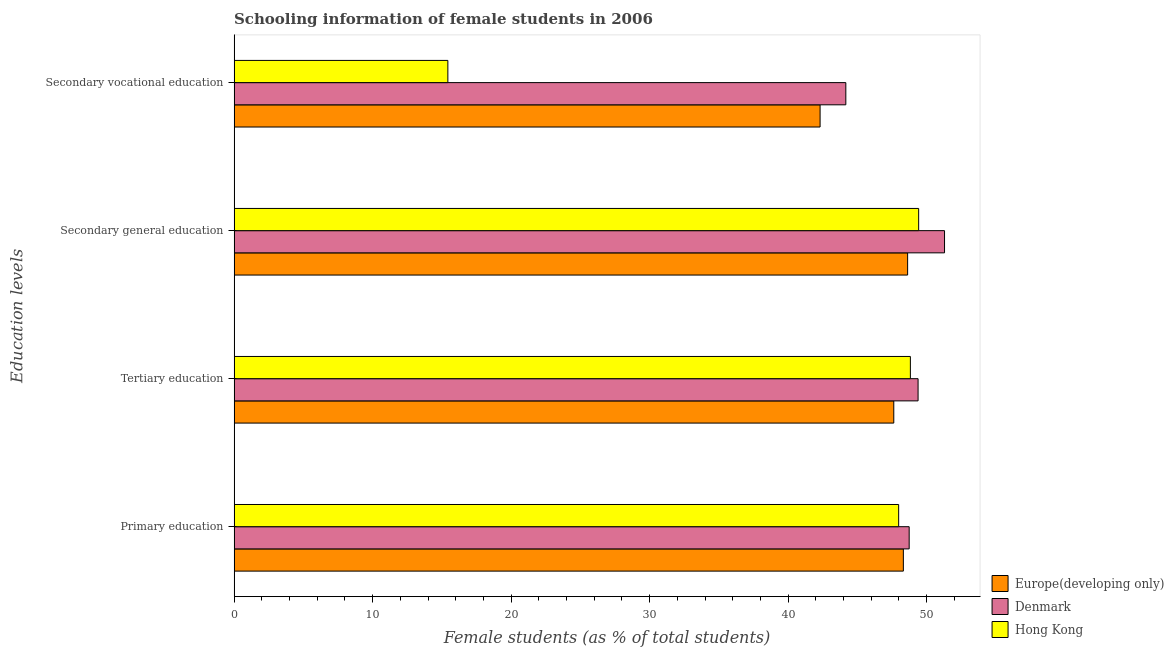How many groups of bars are there?
Give a very brief answer. 4. How many bars are there on the 1st tick from the bottom?
Provide a short and direct response. 3. What is the label of the 2nd group of bars from the top?
Your response must be concise. Secondary general education. What is the percentage of female students in secondary education in Hong Kong?
Keep it short and to the point. 49.42. Across all countries, what is the maximum percentage of female students in secondary vocational education?
Give a very brief answer. 44.16. Across all countries, what is the minimum percentage of female students in secondary vocational education?
Make the answer very short. 15.43. In which country was the percentage of female students in secondary vocational education minimum?
Give a very brief answer. Hong Kong. What is the total percentage of female students in primary education in the graph?
Your response must be concise. 145.03. What is the difference between the percentage of female students in secondary vocational education in Europe(developing only) and that in Hong Kong?
Ensure brevity in your answer.  26.88. What is the difference between the percentage of female students in primary education in Europe(developing only) and the percentage of female students in tertiary education in Hong Kong?
Ensure brevity in your answer.  -0.51. What is the average percentage of female students in secondary education per country?
Offer a very short reply. 49.78. What is the difference between the percentage of female students in secondary education and percentage of female students in tertiary education in Hong Kong?
Your response must be concise. 0.6. In how many countries, is the percentage of female students in tertiary education greater than 10 %?
Offer a terse response. 3. What is the ratio of the percentage of female students in tertiary education in Hong Kong to that in Denmark?
Your response must be concise. 0.99. Is the difference between the percentage of female students in primary education in Denmark and Hong Kong greater than the difference between the percentage of female students in secondary education in Denmark and Hong Kong?
Your answer should be very brief. No. What is the difference between the highest and the second highest percentage of female students in primary education?
Provide a short and direct response. 0.42. What is the difference between the highest and the lowest percentage of female students in tertiary education?
Your answer should be very brief. 1.75. What does the 3rd bar from the top in Secondary vocational education represents?
Provide a succinct answer. Europe(developing only). What does the 2nd bar from the bottom in Tertiary education represents?
Provide a short and direct response. Denmark. How many bars are there?
Offer a very short reply. 12. What is the difference between two consecutive major ticks on the X-axis?
Offer a very short reply. 10. Does the graph contain grids?
Ensure brevity in your answer.  No. Where does the legend appear in the graph?
Give a very brief answer. Bottom right. What is the title of the graph?
Provide a short and direct response. Schooling information of female students in 2006. What is the label or title of the X-axis?
Offer a very short reply. Female students (as % of total students). What is the label or title of the Y-axis?
Your response must be concise. Education levels. What is the Female students (as % of total students) of Europe(developing only) in Primary education?
Give a very brief answer. 48.32. What is the Female students (as % of total students) in Denmark in Primary education?
Provide a short and direct response. 48.74. What is the Female students (as % of total students) in Hong Kong in Primary education?
Give a very brief answer. 47.98. What is the Female students (as % of total students) in Europe(developing only) in Tertiary education?
Give a very brief answer. 47.63. What is the Female students (as % of total students) of Denmark in Tertiary education?
Provide a succinct answer. 49.38. What is the Female students (as % of total students) of Hong Kong in Tertiary education?
Make the answer very short. 48.82. What is the Female students (as % of total students) of Europe(developing only) in Secondary general education?
Ensure brevity in your answer.  48.63. What is the Female students (as % of total students) in Denmark in Secondary general education?
Offer a terse response. 51.29. What is the Female students (as % of total students) in Hong Kong in Secondary general education?
Your answer should be compact. 49.42. What is the Female students (as % of total students) of Europe(developing only) in Secondary vocational education?
Your answer should be compact. 42.31. What is the Female students (as % of total students) in Denmark in Secondary vocational education?
Provide a short and direct response. 44.16. What is the Female students (as % of total students) of Hong Kong in Secondary vocational education?
Give a very brief answer. 15.43. Across all Education levels, what is the maximum Female students (as % of total students) of Europe(developing only)?
Give a very brief answer. 48.63. Across all Education levels, what is the maximum Female students (as % of total students) of Denmark?
Make the answer very short. 51.29. Across all Education levels, what is the maximum Female students (as % of total students) of Hong Kong?
Offer a terse response. 49.42. Across all Education levels, what is the minimum Female students (as % of total students) in Europe(developing only)?
Your response must be concise. 42.31. Across all Education levels, what is the minimum Female students (as % of total students) of Denmark?
Your answer should be very brief. 44.16. Across all Education levels, what is the minimum Female students (as % of total students) in Hong Kong?
Provide a short and direct response. 15.43. What is the total Female students (as % of total students) in Europe(developing only) in the graph?
Make the answer very short. 186.88. What is the total Female students (as % of total students) of Denmark in the graph?
Offer a terse response. 193.57. What is the total Female students (as % of total students) of Hong Kong in the graph?
Provide a succinct answer. 161.66. What is the difference between the Female students (as % of total students) in Europe(developing only) in Primary education and that in Tertiary education?
Give a very brief answer. 0.69. What is the difference between the Female students (as % of total students) in Denmark in Primary education and that in Tertiary education?
Make the answer very short. -0.64. What is the difference between the Female students (as % of total students) in Hong Kong in Primary education and that in Tertiary education?
Your answer should be very brief. -0.85. What is the difference between the Female students (as % of total students) in Europe(developing only) in Primary education and that in Secondary general education?
Give a very brief answer. -0.31. What is the difference between the Female students (as % of total students) of Denmark in Primary education and that in Secondary general education?
Ensure brevity in your answer.  -2.55. What is the difference between the Female students (as % of total students) of Hong Kong in Primary education and that in Secondary general education?
Your response must be concise. -1.44. What is the difference between the Female students (as % of total students) of Europe(developing only) in Primary education and that in Secondary vocational education?
Provide a succinct answer. 6.01. What is the difference between the Female students (as % of total students) of Denmark in Primary education and that in Secondary vocational education?
Provide a short and direct response. 4.57. What is the difference between the Female students (as % of total students) of Hong Kong in Primary education and that in Secondary vocational education?
Your answer should be compact. 32.55. What is the difference between the Female students (as % of total students) in Europe(developing only) in Tertiary education and that in Secondary general education?
Offer a terse response. -1. What is the difference between the Female students (as % of total students) of Denmark in Tertiary education and that in Secondary general education?
Provide a succinct answer. -1.91. What is the difference between the Female students (as % of total students) in Hong Kong in Tertiary education and that in Secondary general education?
Your answer should be compact. -0.6. What is the difference between the Female students (as % of total students) of Europe(developing only) in Tertiary education and that in Secondary vocational education?
Keep it short and to the point. 5.32. What is the difference between the Female students (as % of total students) of Denmark in Tertiary education and that in Secondary vocational education?
Your response must be concise. 5.22. What is the difference between the Female students (as % of total students) in Hong Kong in Tertiary education and that in Secondary vocational education?
Offer a terse response. 33.39. What is the difference between the Female students (as % of total students) in Europe(developing only) in Secondary general education and that in Secondary vocational education?
Make the answer very short. 6.32. What is the difference between the Female students (as % of total students) of Denmark in Secondary general education and that in Secondary vocational education?
Your response must be concise. 7.13. What is the difference between the Female students (as % of total students) in Hong Kong in Secondary general education and that in Secondary vocational education?
Give a very brief answer. 33.99. What is the difference between the Female students (as % of total students) of Europe(developing only) in Primary education and the Female students (as % of total students) of Denmark in Tertiary education?
Give a very brief answer. -1.06. What is the difference between the Female students (as % of total students) of Europe(developing only) in Primary education and the Female students (as % of total students) of Hong Kong in Tertiary education?
Your response must be concise. -0.51. What is the difference between the Female students (as % of total students) of Denmark in Primary education and the Female students (as % of total students) of Hong Kong in Tertiary education?
Keep it short and to the point. -0.09. What is the difference between the Female students (as % of total students) in Europe(developing only) in Primary education and the Female students (as % of total students) in Denmark in Secondary general education?
Provide a succinct answer. -2.97. What is the difference between the Female students (as % of total students) in Europe(developing only) in Primary education and the Female students (as % of total students) in Hong Kong in Secondary general education?
Make the answer very short. -1.11. What is the difference between the Female students (as % of total students) of Denmark in Primary education and the Female students (as % of total students) of Hong Kong in Secondary general education?
Provide a short and direct response. -0.68. What is the difference between the Female students (as % of total students) of Europe(developing only) in Primary education and the Female students (as % of total students) of Denmark in Secondary vocational education?
Offer a terse response. 4.15. What is the difference between the Female students (as % of total students) of Europe(developing only) in Primary education and the Female students (as % of total students) of Hong Kong in Secondary vocational education?
Provide a short and direct response. 32.89. What is the difference between the Female students (as % of total students) in Denmark in Primary education and the Female students (as % of total students) in Hong Kong in Secondary vocational education?
Ensure brevity in your answer.  33.31. What is the difference between the Female students (as % of total students) of Europe(developing only) in Tertiary education and the Female students (as % of total students) of Denmark in Secondary general education?
Your answer should be very brief. -3.66. What is the difference between the Female students (as % of total students) in Europe(developing only) in Tertiary education and the Female students (as % of total students) in Hong Kong in Secondary general education?
Give a very brief answer. -1.8. What is the difference between the Female students (as % of total students) of Denmark in Tertiary education and the Female students (as % of total students) of Hong Kong in Secondary general education?
Ensure brevity in your answer.  -0.04. What is the difference between the Female students (as % of total students) of Europe(developing only) in Tertiary education and the Female students (as % of total students) of Denmark in Secondary vocational education?
Provide a succinct answer. 3.46. What is the difference between the Female students (as % of total students) in Europe(developing only) in Tertiary education and the Female students (as % of total students) in Hong Kong in Secondary vocational education?
Ensure brevity in your answer.  32.2. What is the difference between the Female students (as % of total students) in Denmark in Tertiary education and the Female students (as % of total students) in Hong Kong in Secondary vocational education?
Your answer should be compact. 33.95. What is the difference between the Female students (as % of total students) in Europe(developing only) in Secondary general education and the Female students (as % of total students) in Denmark in Secondary vocational education?
Provide a succinct answer. 4.46. What is the difference between the Female students (as % of total students) in Europe(developing only) in Secondary general education and the Female students (as % of total students) in Hong Kong in Secondary vocational education?
Ensure brevity in your answer.  33.19. What is the difference between the Female students (as % of total students) of Denmark in Secondary general education and the Female students (as % of total students) of Hong Kong in Secondary vocational education?
Provide a short and direct response. 35.86. What is the average Female students (as % of total students) of Europe(developing only) per Education levels?
Offer a terse response. 46.72. What is the average Female students (as % of total students) in Denmark per Education levels?
Provide a short and direct response. 48.39. What is the average Female students (as % of total students) in Hong Kong per Education levels?
Keep it short and to the point. 40.41. What is the difference between the Female students (as % of total students) in Europe(developing only) and Female students (as % of total students) in Denmark in Primary education?
Provide a succinct answer. -0.42. What is the difference between the Female students (as % of total students) in Europe(developing only) and Female students (as % of total students) in Hong Kong in Primary education?
Ensure brevity in your answer.  0.34. What is the difference between the Female students (as % of total students) in Denmark and Female students (as % of total students) in Hong Kong in Primary education?
Offer a very short reply. 0.76. What is the difference between the Female students (as % of total students) of Europe(developing only) and Female students (as % of total students) of Denmark in Tertiary education?
Your response must be concise. -1.75. What is the difference between the Female students (as % of total students) in Europe(developing only) and Female students (as % of total students) in Hong Kong in Tertiary education?
Make the answer very short. -1.2. What is the difference between the Female students (as % of total students) in Denmark and Female students (as % of total students) in Hong Kong in Tertiary education?
Provide a succinct answer. 0.56. What is the difference between the Female students (as % of total students) of Europe(developing only) and Female students (as % of total students) of Denmark in Secondary general education?
Your answer should be very brief. -2.66. What is the difference between the Female students (as % of total students) of Europe(developing only) and Female students (as % of total students) of Hong Kong in Secondary general education?
Offer a very short reply. -0.8. What is the difference between the Female students (as % of total students) in Denmark and Female students (as % of total students) in Hong Kong in Secondary general education?
Your answer should be compact. 1.87. What is the difference between the Female students (as % of total students) in Europe(developing only) and Female students (as % of total students) in Denmark in Secondary vocational education?
Your answer should be compact. -1.86. What is the difference between the Female students (as % of total students) in Europe(developing only) and Female students (as % of total students) in Hong Kong in Secondary vocational education?
Make the answer very short. 26.88. What is the difference between the Female students (as % of total students) of Denmark and Female students (as % of total students) of Hong Kong in Secondary vocational education?
Your response must be concise. 28.73. What is the ratio of the Female students (as % of total students) in Europe(developing only) in Primary education to that in Tertiary education?
Provide a succinct answer. 1.01. What is the ratio of the Female students (as % of total students) of Hong Kong in Primary education to that in Tertiary education?
Your answer should be compact. 0.98. What is the ratio of the Female students (as % of total students) in Europe(developing only) in Primary education to that in Secondary general education?
Ensure brevity in your answer.  0.99. What is the ratio of the Female students (as % of total students) of Denmark in Primary education to that in Secondary general education?
Offer a very short reply. 0.95. What is the ratio of the Female students (as % of total students) in Hong Kong in Primary education to that in Secondary general education?
Ensure brevity in your answer.  0.97. What is the ratio of the Female students (as % of total students) in Europe(developing only) in Primary education to that in Secondary vocational education?
Your answer should be compact. 1.14. What is the ratio of the Female students (as % of total students) of Denmark in Primary education to that in Secondary vocational education?
Provide a succinct answer. 1.1. What is the ratio of the Female students (as % of total students) in Hong Kong in Primary education to that in Secondary vocational education?
Make the answer very short. 3.11. What is the ratio of the Female students (as % of total students) in Europe(developing only) in Tertiary education to that in Secondary general education?
Your answer should be compact. 0.98. What is the ratio of the Female students (as % of total students) in Denmark in Tertiary education to that in Secondary general education?
Your response must be concise. 0.96. What is the ratio of the Female students (as % of total students) in Hong Kong in Tertiary education to that in Secondary general education?
Give a very brief answer. 0.99. What is the ratio of the Female students (as % of total students) of Europe(developing only) in Tertiary education to that in Secondary vocational education?
Ensure brevity in your answer.  1.13. What is the ratio of the Female students (as % of total students) in Denmark in Tertiary education to that in Secondary vocational education?
Give a very brief answer. 1.12. What is the ratio of the Female students (as % of total students) of Hong Kong in Tertiary education to that in Secondary vocational education?
Ensure brevity in your answer.  3.16. What is the ratio of the Female students (as % of total students) of Europe(developing only) in Secondary general education to that in Secondary vocational education?
Keep it short and to the point. 1.15. What is the ratio of the Female students (as % of total students) of Denmark in Secondary general education to that in Secondary vocational education?
Offer a terse response. 1.16. What is the ratio of the Female students (as % of total students) of Hong Kong in Secondary general education to that in Secondary vocational education?
Ensure brevity in your answer.  3.2. What is the difference between the highest and the second highest Female students (as % of total students) in Europe(developing only)?
Make the answer very short. 0.31. What is the difference between the highest and the second highest Female students (as % of total students) of Denmark?
Keep it short and to the point. 1.91. What is the difference between the highest and the second highest Female students (as % of total students) of Hong Kong?
Make the answer very short. 0.6. What is the difference between the highest and the lowest Female students (as % of total students) in Europe(developing only)?
Provide a short and direct response. 6.32. What is the difference between the highest and the lowest Female students (as % of total students) of Denmark?
Provide a short and direct response. 7.13. What is the difference between the highest and the lowest Female students (as % of total students) of Hong Kong?
Your answer should be compact. 33.99. 